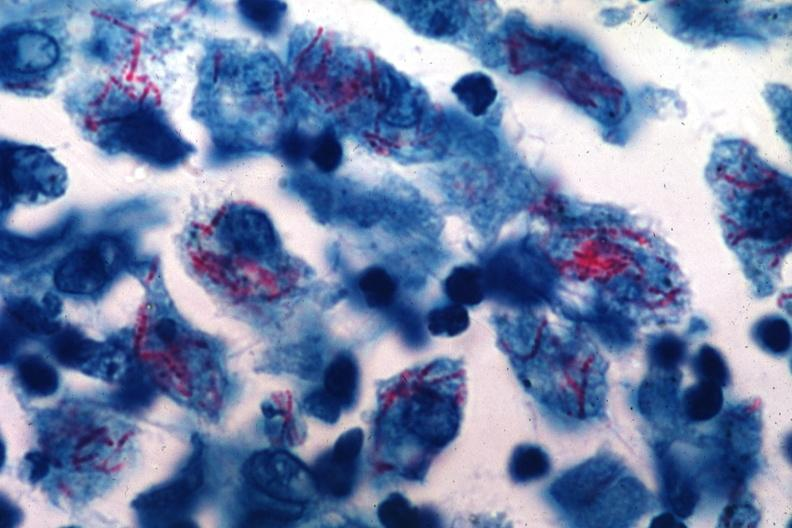what is present?
Answer the question using a single word or phrase. Lymph node 